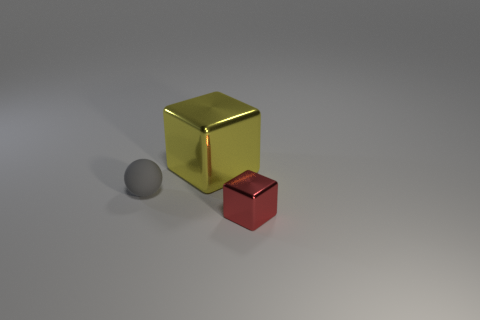What kind of texture do the surfaces of these objects have? From the image, the surfaces of both objects show differing textures. The golden cube exhibits a smooth and shiny texture, reflecting light and giving it a glossy finish. In contrast, the red cube, though also fairly smooth, has a less reflective surface, indicating a possibly semi-matte texture which doesn't reflect light as vividly. The gray sphere has an almost perfectly matte finish, absorbing light uniformly and showing no reflection, which could make it feel softer to touch. 